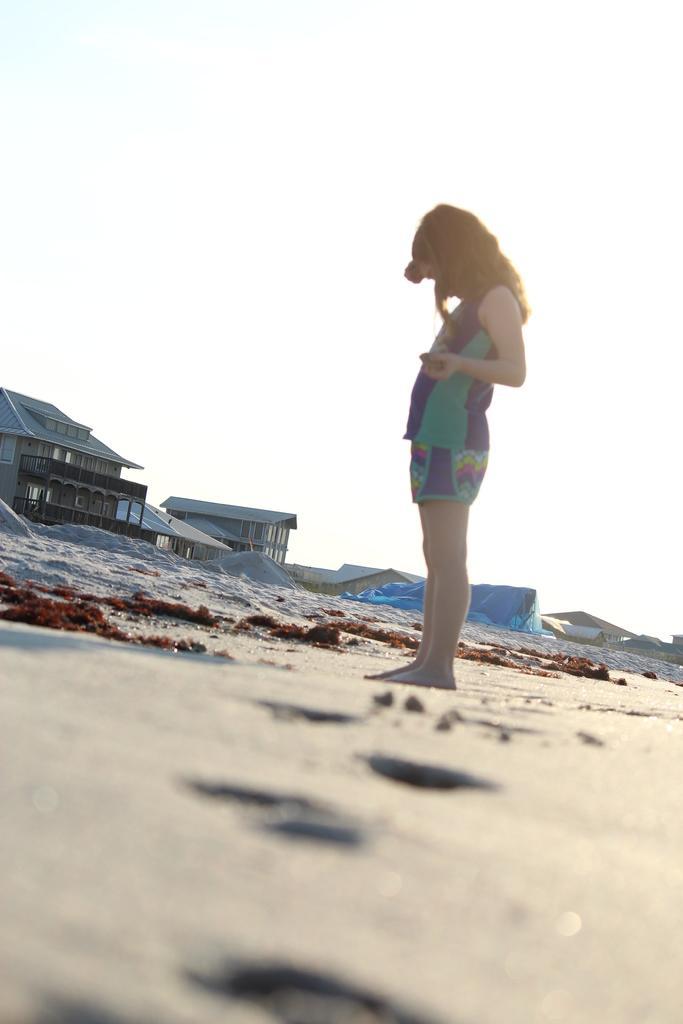Please provide a concise description of this image. In this image I can see a girl is standing. I can see she is wearing blue and green colour dress. In the background I can see few buildings, a blue colour thing and I can see white colour in background. 